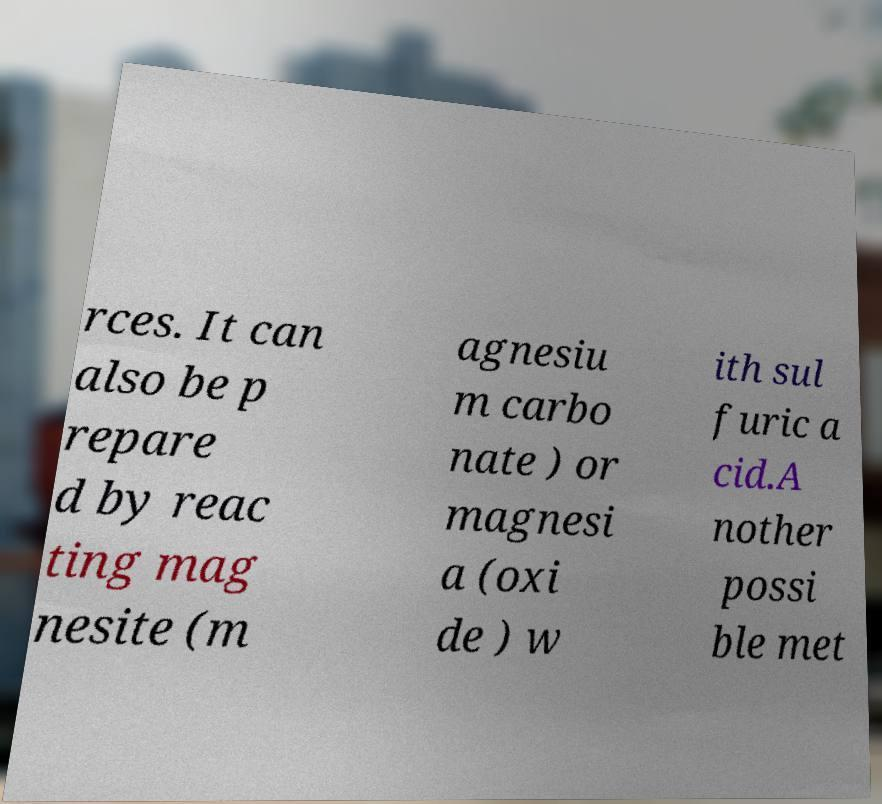I need the written content from this picture converted into text. Can you do that? rces. It can also be p repare d by reac ting mag nesite (m agnesiu m carbo nate ) or magnesi a (oxi de ) w ith sul furic a cid.A nother possi ble met 